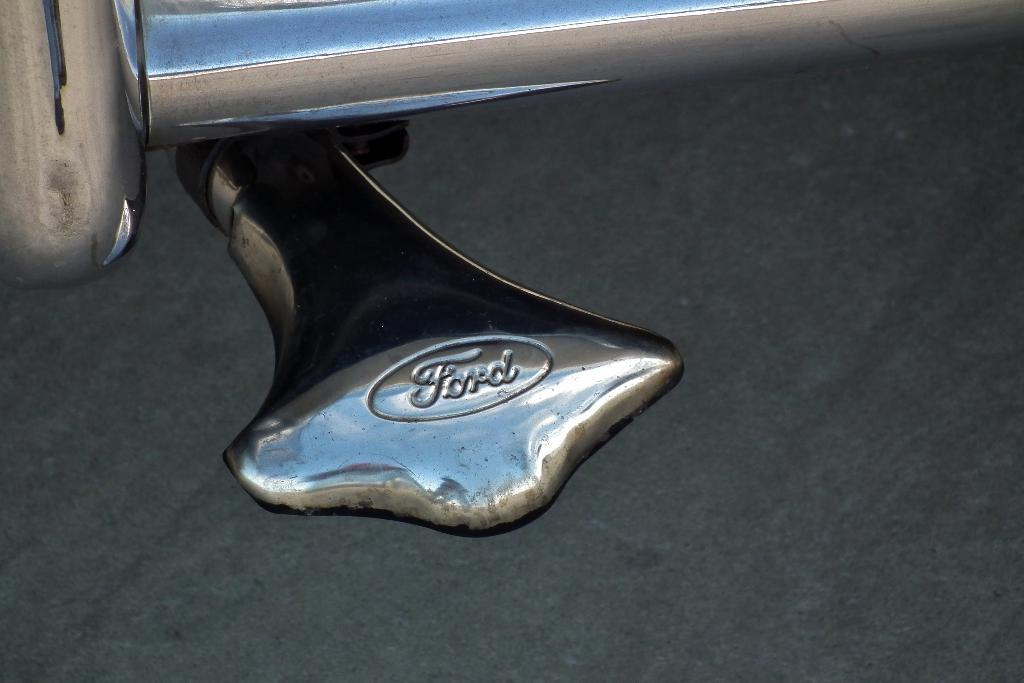What is the main subject in the front of the image? There is an object in the front of the image. What is the color of the object? The object is silver in color. Is there any text on the object? Yes, there is text written on the object. What type of truck is visible in the image? There is no truck present in the image. What is the size of the button on the object? There is no button present on the object in the image. 